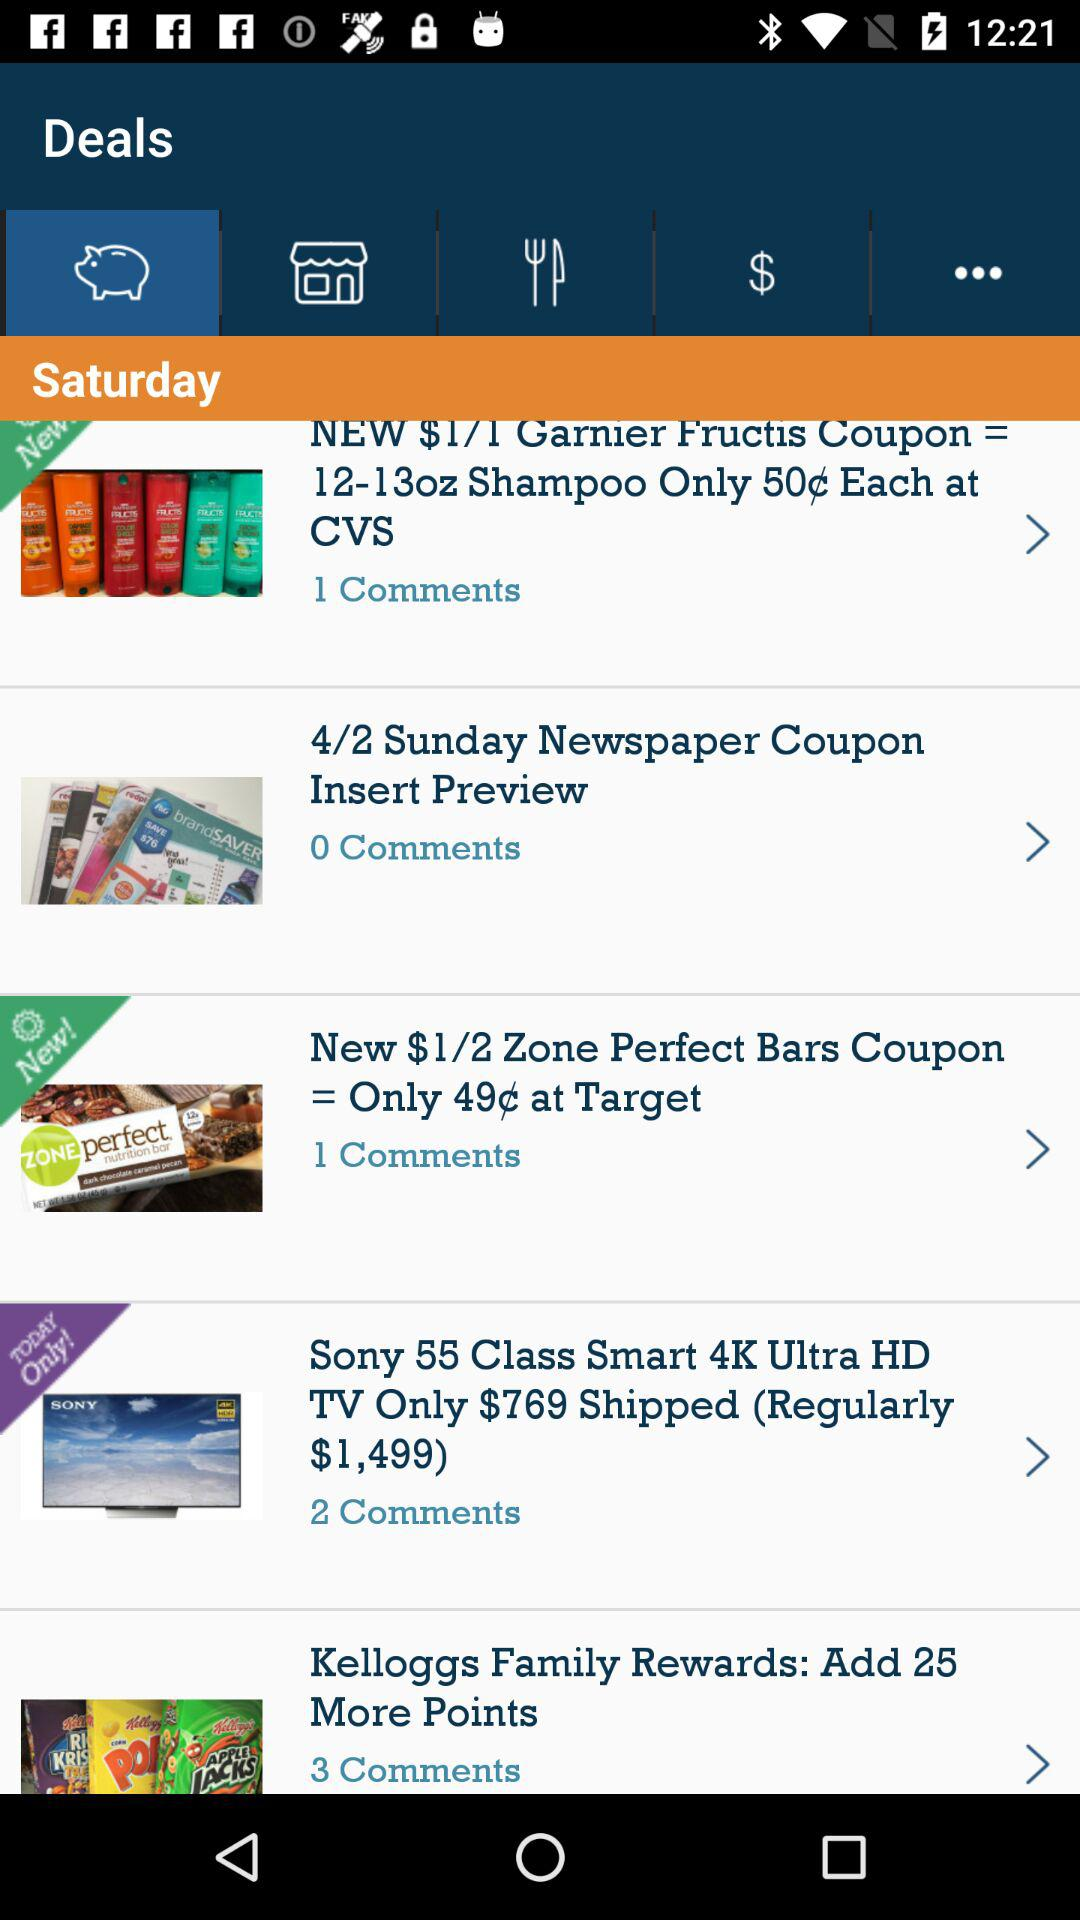What is the given day? The day is Saturday. 